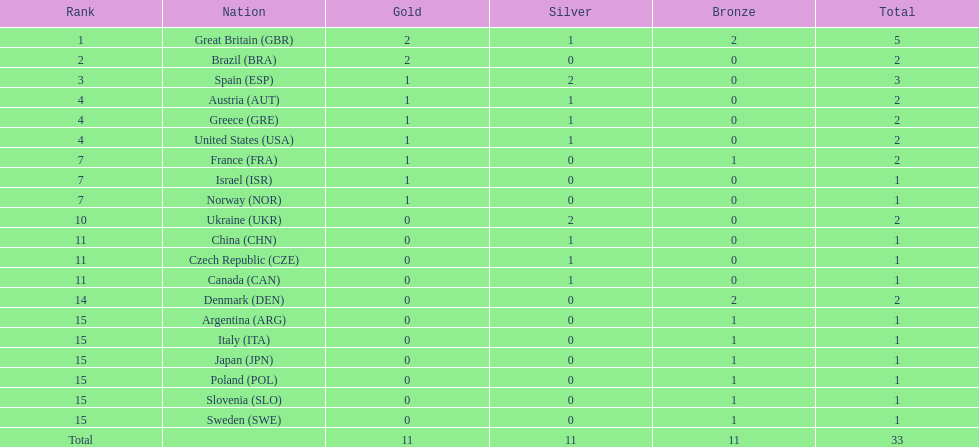Can you parse all the data within this table? {'header': ['Rank', 'Nation', 'Gold', 'Silver', 'Bronze', 'Total'], 'rows': [['1', 'Great Britain\xa0(GBR)', '2', '1', '2', '5'], ['2', 'Brazil\xa0(BRA)', '2', '0', '0', '2'], ['3', 'Spain\xa0(ESP)', '1', '2', '0', '3'], ['4', 'Austria\xa0(AUT)', '1', '1', '0', '2'], ['4', 'Greece\xa0(GRE)', '1', '1', '0', '2'], ['4', 'United States\xa0(USA)', '1', '1', '0', '2'], ['7', 'France\xa0(FRA)', '1', '0', '1', '2'], ['7', 'Israel\xa0(ISR)', '1', '0', '0', '1'], ['7', 'Norway\xa0(NOR)', '1', '0', '0', '1'], ['10', 'Ukraine\xa0(UKR)', '0', '2', '0', '2'], ['11', 'China\xa0(CHN)', '0', '1', '0', '1'], ['11', 'Czech Republic\xa0(CZE)', '0', '1', '0', '1'], ['11', 'Canada\xa0(CAN)', '0', '1', '0', '1'], ['14', 'Denmark\xa0(DEN)', '0', '0', '2', '2'], ['15', 'Argentina\xa0(ARG)', '0', '0', '1', '1'], ['15', 'Italy\xa0(ITA)', '0', '0', '1', '1'], ['15', 'Japan\xa0(JPN)', '0', '0', '1', '1'], ['15', 'Poland\xa0(POL)', '0', '0', '1', '1'], ['15', 'Slovenia\xa0(SLO)', '0', '0', '1', '1'], ['15', 'Sweden\xa0(SWE)', '0', '0', '1', '1'], ['Total', '', '11', '11', '11', '33']]} How many gold medals did italy receive? 0. 